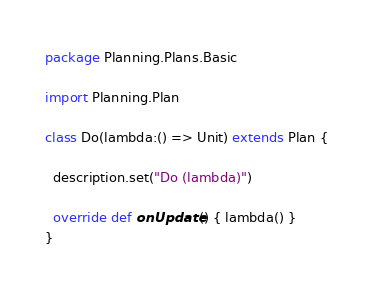Convert code to text. <code><loc_0><loc_0><loc_500><loc_500><_Scala_>package Planning.Plans.Basic

import Planning.Plan

class Do(lambda:() => Unit) extends Plan {
  
  description.set("Do (lambda)")
  
  override def onUpdate() { lambda() }
}
</code> 